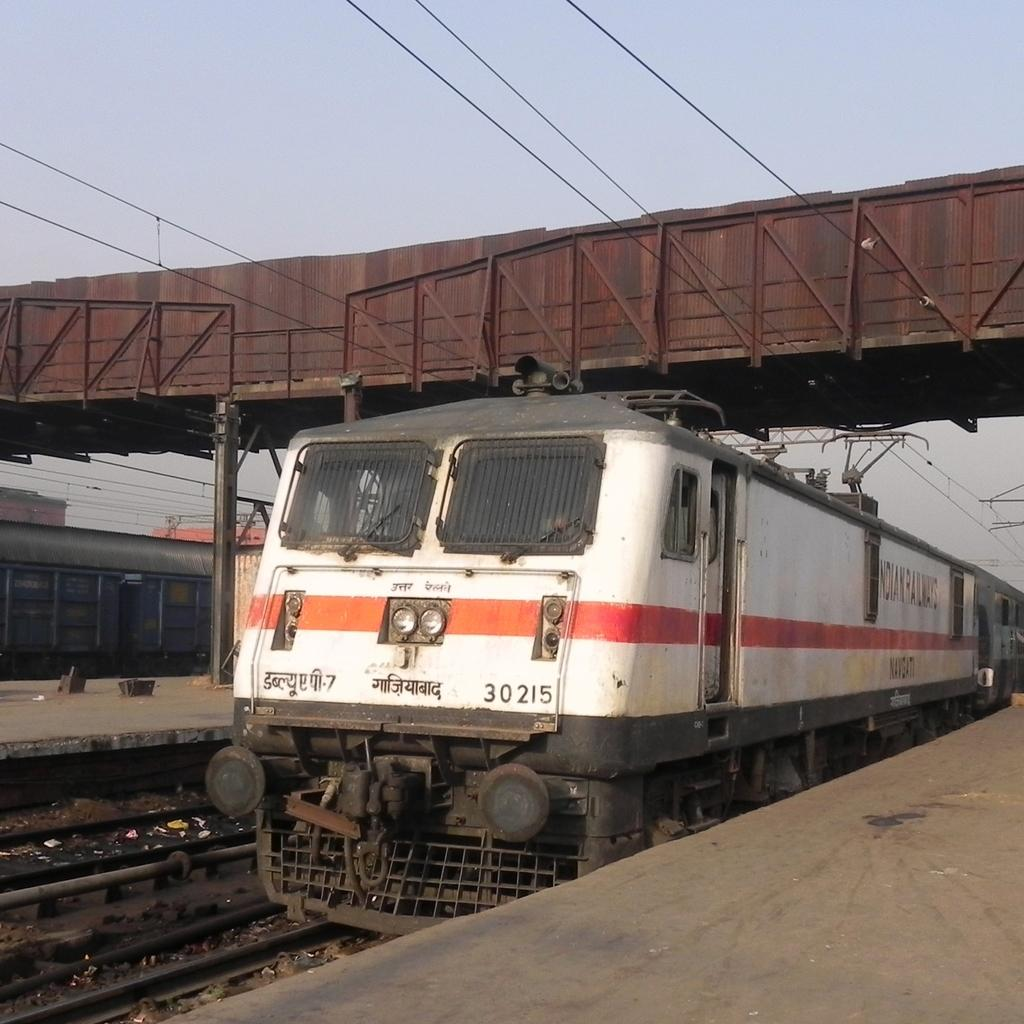What is the main subject of the image? The main subject of the image is a train. What colors are used to paint the train? The train is in white and red colors. Where is the train located in the image? The train is on a track. Can you see any other trains in the image? Yes, there is another train visible in the background. What is the color of the sky in the image? The sky is gray in color. Are there any structures visible in the image? Yes, there is a bridge in the image. Where is the crowd gathered in the image? There is no crowd present in the image. What type of event is taking place near the train in the image? There is no event taking place in the image. 